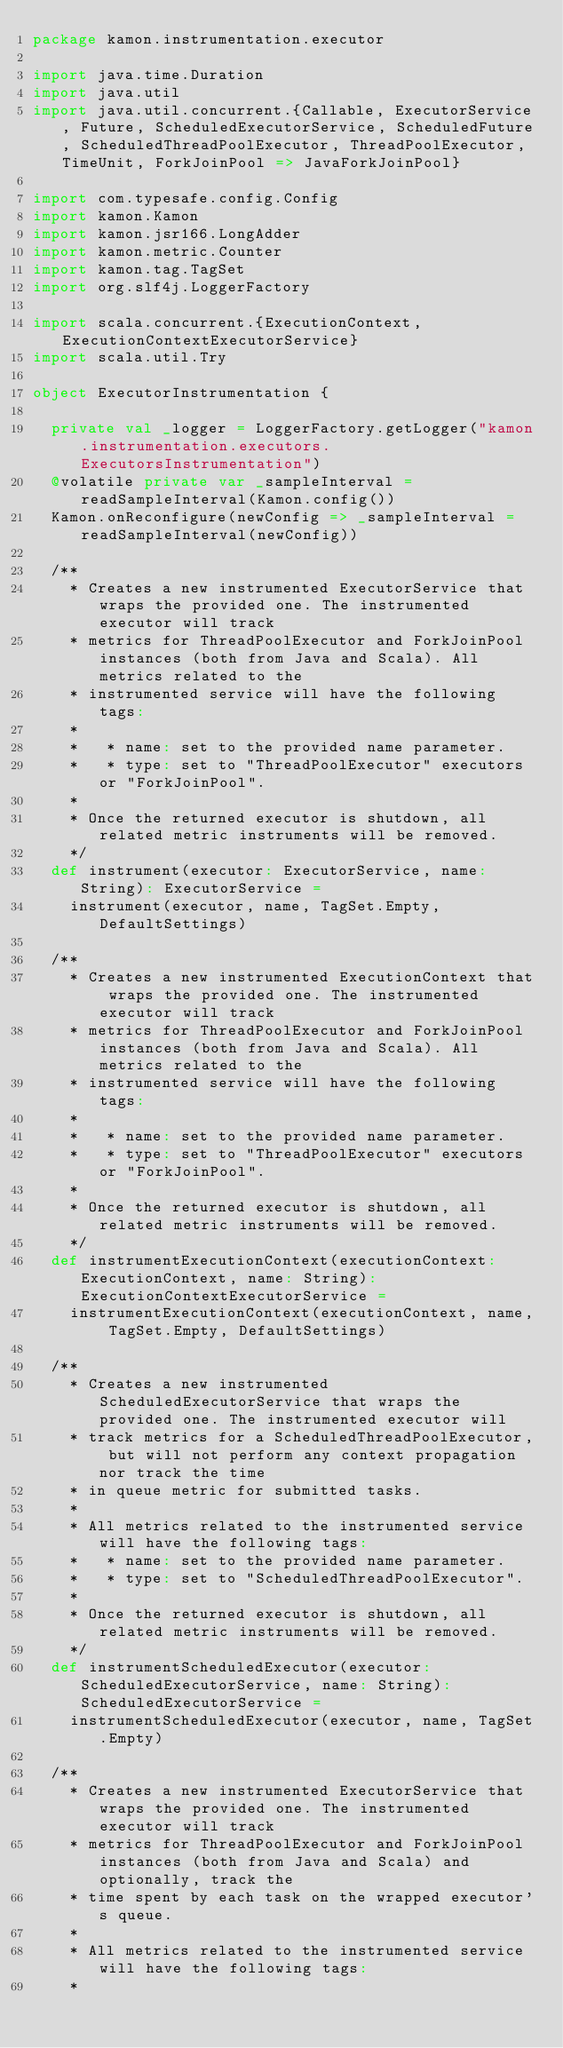Convert code to text. <code><loc_0><loc_0><loc_500><loc_500><_Scala_>package kamon.instrumentation.executor

import java.time.Duration
import java.util
import java.util.concurrent.{Callable, ExecutorService, Future, ScheduledExecutorService, ScheduledFuture, ScheduledThreadPoolExecutor, ThreadPoolExecutor, TimeUnit, ForkJoinPool => JavaForkJoinPool}

import com.typesafe.config.Config
import kamon.Kamon
import kamon.jsr166.LongAdder
import kamon.metric.Counter
import kamon.tag.TagSet
import org.slf4j.LoggerFactory

import scala.concurrent.{ExecutionContext, ExecutionContextExecutorService}
import scala.util.Try

object ExecutorInstrumentation {

  private val _logger = LoggerFactory.getLogger("kamon.instrumentation.executors.ExecutorsInstrumentation")
  @volatile private var _sampleInterval = readSampleInterval(Kamon.config())
  Kamon.onReconfigure(newConfig => _sampleInterval = readSampleInterval(newConfig))

  /**
    * Creates a new instrumented ExecutorService that wraps the provided one. The instrumented executor will track
    * metrics for ThreadPoolExecutor and ForkJoinPool instances (both from Java and Scala). All metrics related to the
    * instrumented service will have the following tags:
    *
    *   * name: set to the provided name parameter.
    *   * type: set to "ThreadPoolExecutor" executors or "ForkJoinPool".
    *
    * Once the returned executor is shutdown, all related metric instruments will be removed.
    */
  def instrument(executor: ExecutorService, name: String): ExecutorService =
    instrument(executor, name, TagSet.Empty, DefaultSettings)

  /**
    * Creates a new instrumented ExecutionContext that wraps the provided one. The instrumented executor will track
    * metrics for ThreadPoolExecutor and ForkJoinPool instances (both from Java and Scala). All metrics related to the
    * instrumented service will have the following tags:
    *
    *   * name: set to the provided name parameter.
    *   * type: set to "ThreadPoolExecutor" executors or "ForkJoinPool".
    *
    * Once the returned executor is shutdown, all related metric instruments will be removed.
    */
  def instrumentExecutionContext(executionContext: ExecutionContext, name: String): ExecutionContextExecutorService =
    instrumentExecutionContext(executionContext, name, TagSet.Empty, DefaultSettings)

  /**
    * Creates a new instrumented ScheduledExecutorService that wraps the provided one. The instrumented executor will
    * track metrics for a ScheduledThreadPoolExecutor, but will not perform any context propagation nor track the time
    * in queue metric for submitted tasks.
    *
    * All metrics related to the instrumented service will have the following tags:
    *   * name: set to the provided name parameter.
    *   * type: set to "ScheduledThreadPoolExecutor".
    *
    * Once the returned executor is shutdown, all related metric instruments will be removed.
    */
  def instrumentScheduledExecutor(executor: ScheduledExecutorService, name: String): ScheduledExecutorService =
    instrumentScheduledExecutor(executor, name, TagSet.Empty)

  /**
    * Creates a new instrumented ExecutorService that wraps the provided one. The instrumented executor will track
    * metrics for ThreadPoolExecutor and ForkJoinPool instances (both from Java and Scala) and optionally, track the
    * time spent by each task on the wrapped executor's queue.
    *
    * All metrics related to the instrumented service will have the following tags:
    *</code> 